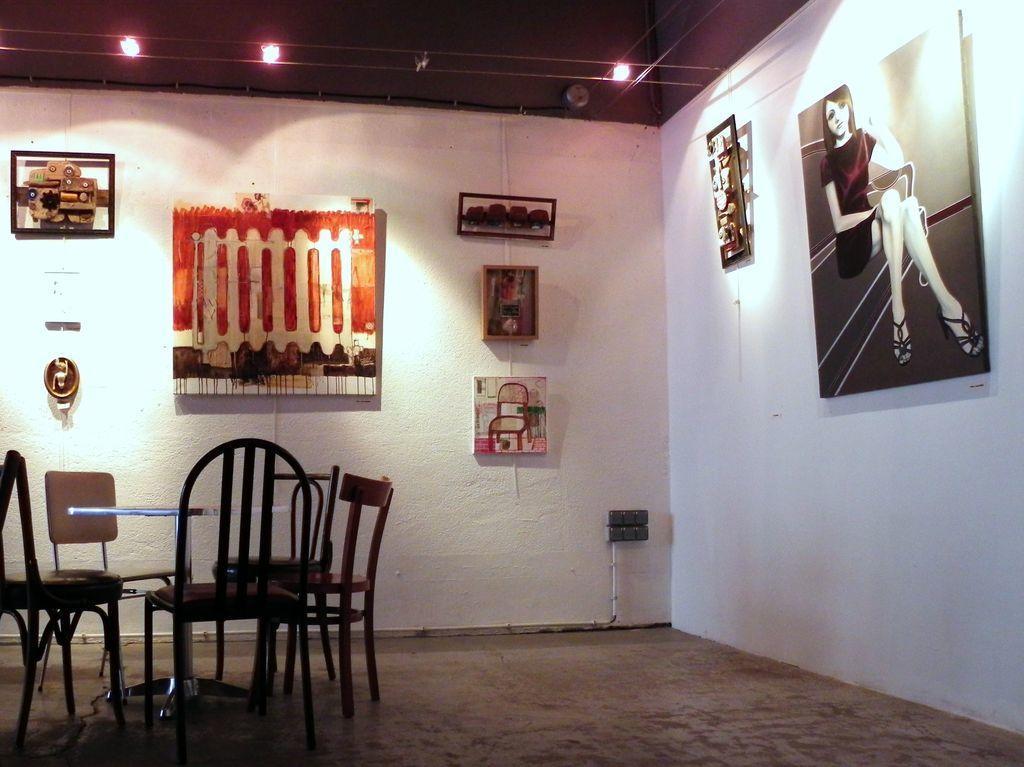Describe this image in one or two sentences. Inside a room there is dining table and in the background there is a wall and there are many posts attached to the wall,the wall is of white color and there are three lights to the roof. 